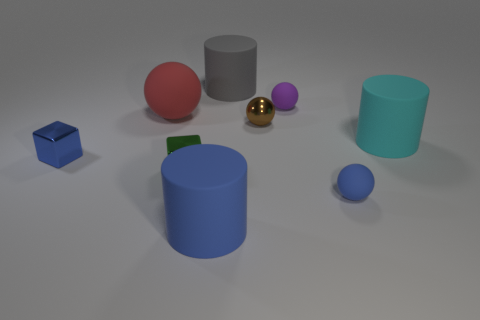Subtract all cylinders. How many objects are left? 6 Subtract all gray objects. Subtract all gray matte things. How many objects are left? 7 Add 9 large cyan things. How many large cyan things are left? 10 Add 5 gray matte cylinders. How many gray matte cylinders exist? 6 Subtract 1 brown spheres. How many objects are left? 8 